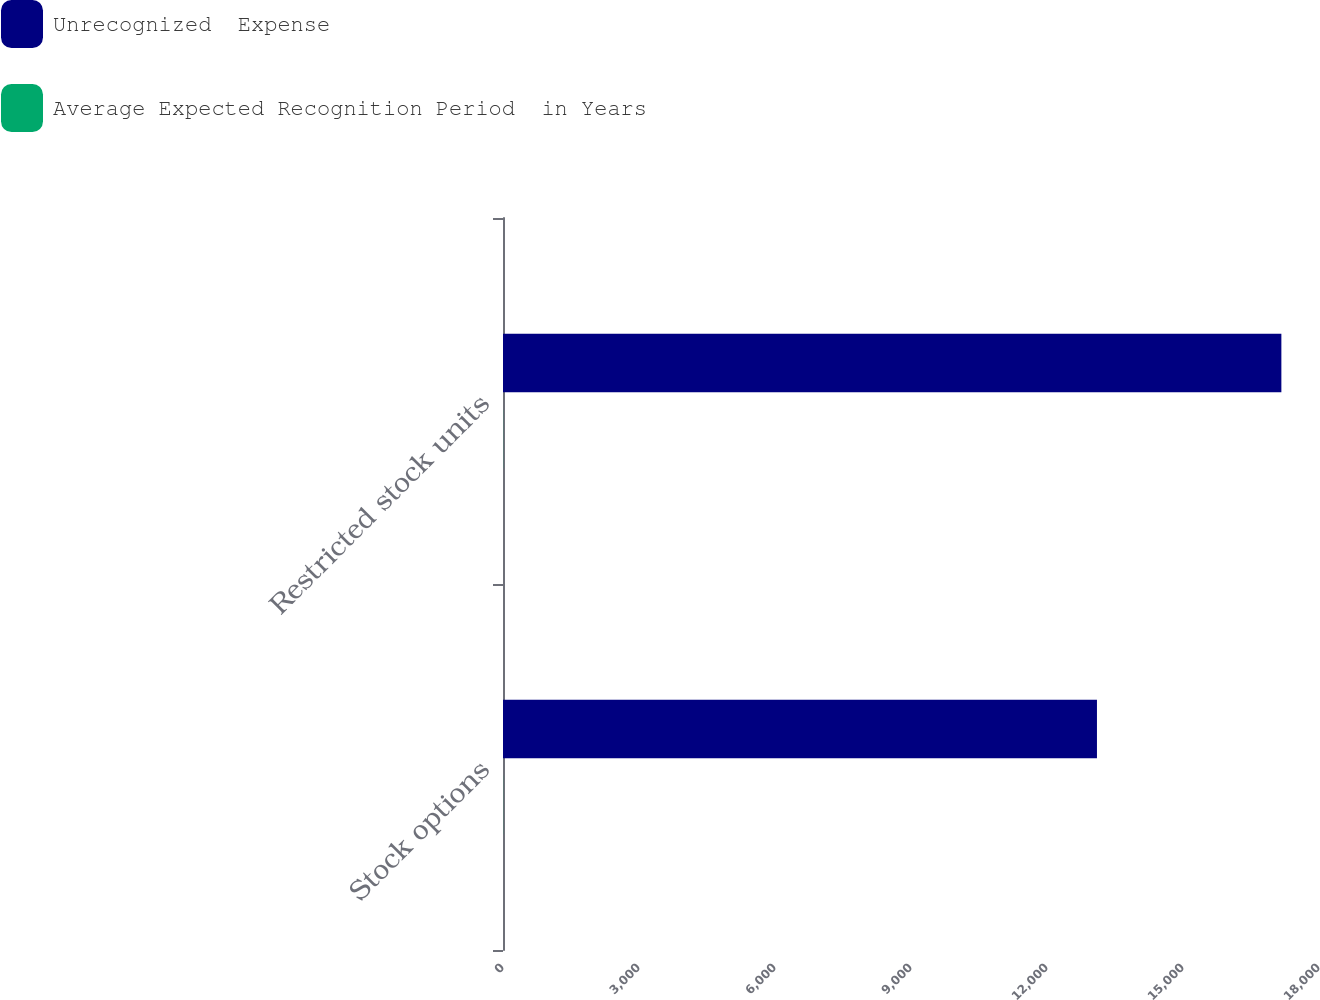<chart> <loc_0><loc_0><loc_500><loc_500><stacked_bar_chart><ecel><fcel>Stock options<fcel>Restricted stock units<nl><fcel>Unrecognized  Expense<fcel>13102<fcel>17170<nl><fcel>Average Expected Recognition Period  in Years<fcel>2.67<fcel>2.74<nl></chart> 